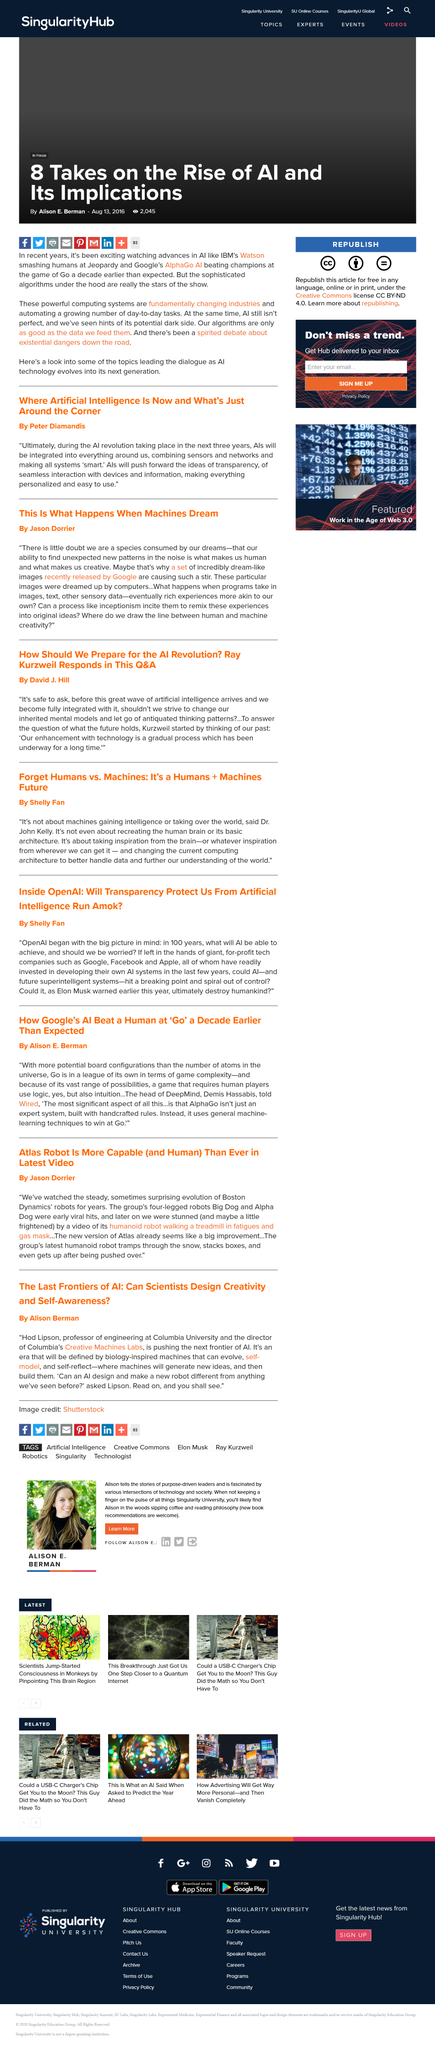Highlight a few significant elements in this photo. The images released by Google were created by computers. Google released the set of dream-like images. The article titled "This Is What Happens When Machines Dream?" was written by Jason Dorrier. 